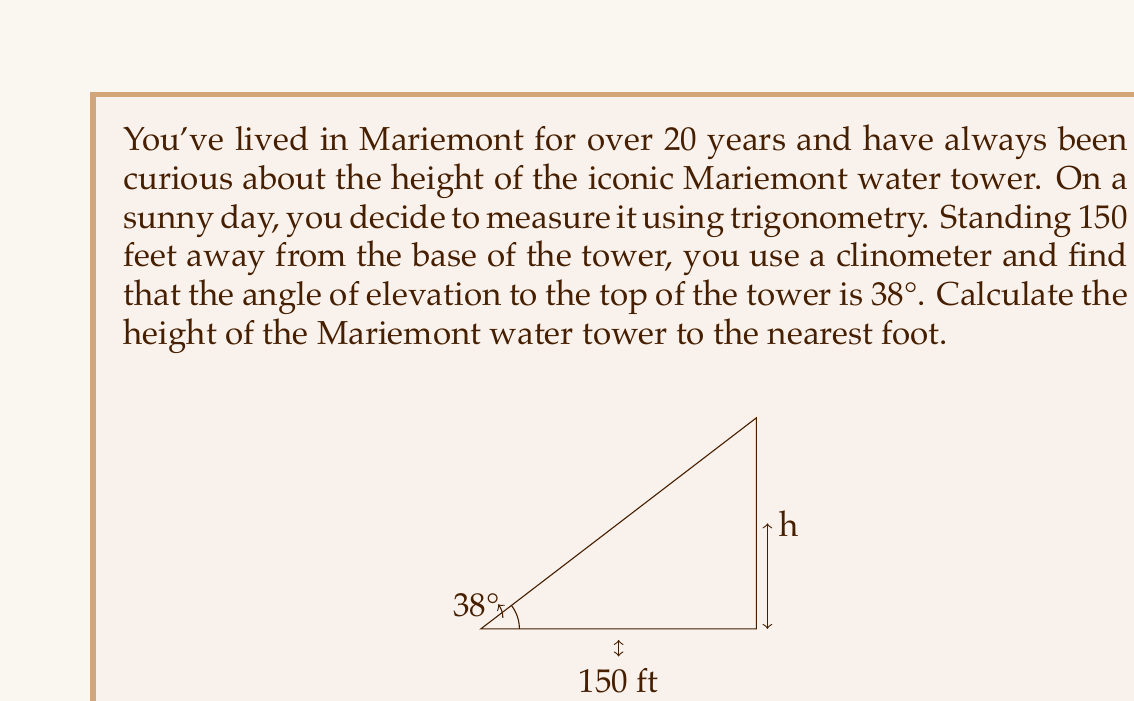Teach me how to tackle this problem. Let's approach this problem step-by-step using trigonometry:

1) In this scenario, we have a right triangle where:
   - The adjacent side is the distance from you to the base of the tower (150 feet)
   - The opposite side is the height of the tower (what we're trying to find)
   - The angle of elevation is 38°

2) We can use the tangent function to solve for the height. Recall that:

   $$\tan(\theta) = \frac{\text{opposite}}{\text{adjacent}}$$

3) Let's call the height of the tower $h$. We can set up the equation:

   $$\tan(38°) = \frac{h}{150}$$

4) To solve for $h$, we multiply both sides by 150:

   $$h = 150 \cdot \tan(38°)$$

5) Now we can calculate:
   
   $$h = 150 \cdot \tan(38°) \approx 150 \cdot 0.7813 \approx 117.195$$

6) Rounding to the nearest foot as requested in the question:

   $$h \approx 117 \text{ feet}$$

Thus, the Mariemont water tower is approximately 117 feet tall.
Answer: The height of the Mariemont water tower is approximately 117 feet. 